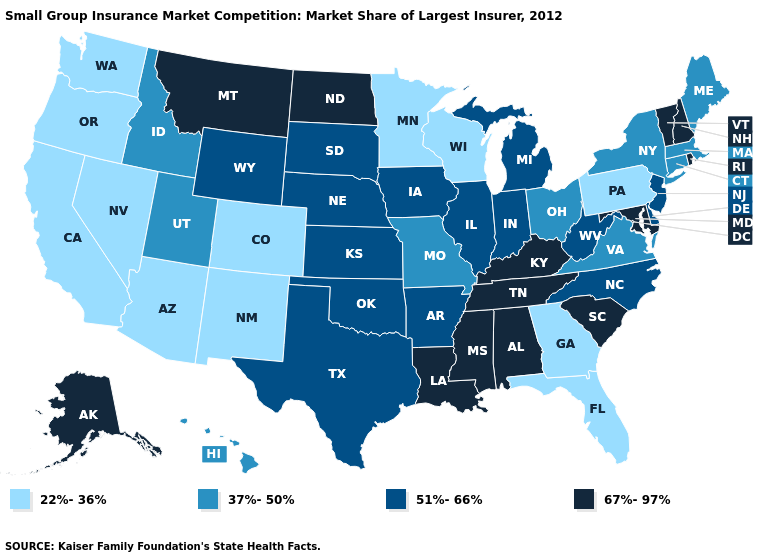Name the states that have a value in the range 51%-66%?
Quick response, please. Arkansas, Delaware, Illinois, Indiana, Iowa, Kansas, Michigan, Nebraska, New Jersey, North Carolina, Oklahoma, South Dakota, Texas, West Virginia, Wyoming. How many symbols are there in the legend?
Short answer required. 4. Does California have the highest value in the West?
Write a very short answer. No. Among the states that border Ohio , which have the highest value?
Give a very brief answer. Kentucky. Does Texas have the highest value in the USA?
Quick response, please. No. Name the states that have a value in the range 67%-97%?
Answer briefly. Alabama, Alaska, Kentucky, Louisiana, Maryland, Mississippi, Montana, New Hampshire, North Dakota, Rhode Island, South Carolina, Tennessee, Vermont. Does Pennsylvania have the lowest value in the Northeast?
Give a very brief answer. Yes. What is the value of Kansas?
Write a very short answer. 51%-66%. Among the states that border Ohio , does Pennsylvania have the lowest value?
Quick response, please. Yes. What is the value of North Dakota?
Short answer required. 67%-97%. Which states have the lowest value in the USA?
Keep it brief. Arizona, California, Colorado, Florida, Georgia, Minnesota, Nevada, New Mexico, Oregon, Pennsylvania, Washington, Wisconsin. Name the states that have a value in the range 37%-50%?
Be succinct. Connecticut, Hawaii, Idaho, Maine, Massachusetts, Missouri, New York, Ohio, Utah, Virginia. What is the value of California?
Quick response, please. 22%-36%. What is the value of New Mexico?
Quick response, please. 22%-36%. 